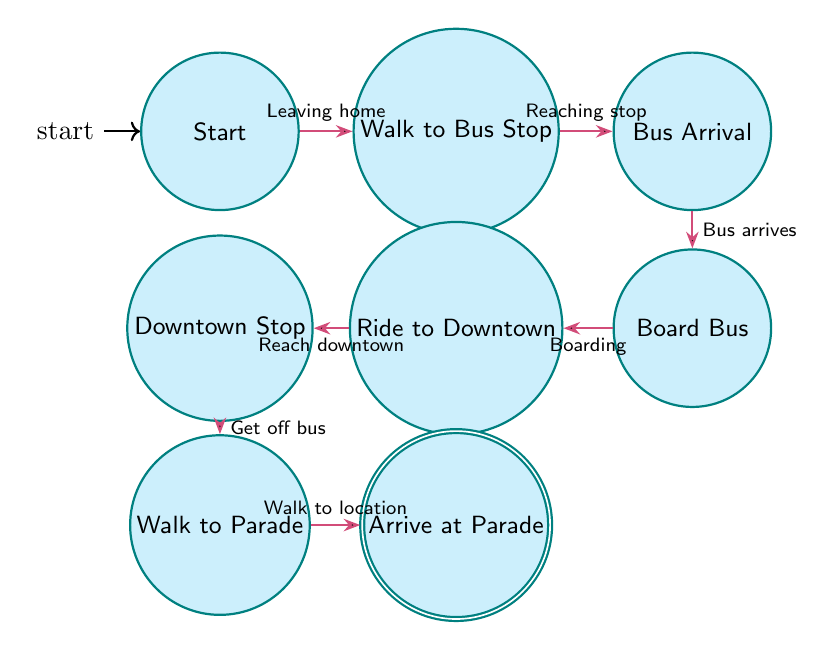What is the starting point in the diagram? The starting point is labeled "Start," which represents the location where a person begins their journey at home in Pittsburgh.
Answer: Start How many states are represented in the diagram? By counting the individual labeled states shown in the diagram, we find a total of 8 states, which include Start, Walk to Bus Stop, Bus Arrival, Board Bus, Ride to Downtown, Downtown Stop, Walk to Parade, and Arrive at Parade.
Answer: 8 What does the arrow from "Board Bus" to "Ride to Downtown" signify? The arrow indicates a transition from the state "Board Bus" to the state "Ride to Downtown," which occurs after boarding the bus. This shows the progress of the journey once the bus has been boarded.
Answer: Boarding What is the destination of the last state "Arrive at Parade"? The last state "Arrive at Parade" indicates the final destination of the journey, which is where the Pittsburgh Pride Parade takes place after following the transit steps.
Answer: Pittsburgh Pride Parade Which state follows "Bus Stop Downtown"? The state that directly follows "Bus Stop Downtown" in the sequence is "Walk to Parade," indicating the next action after getting off the bus downtown.
Answer: Walk to Parade What happens in the "Ride to Downtown" state? In the "Ride to Downtown" state, the individual is traveling on the bus that leads them toward downtown Pittsburgh but hasn't yet reached their stop. This is an operational aspect of their journey.
Answer: Traveling on the bus What is the relationship between "Walk to Bus Stop" and "Bus Arrival"? The relationship is sequential; after reaching the bus stop, the next state is "Bus Arrival," indicating the person waits for the bus after arriving at the stop.
Answer: Sequential What is the transition description from "Walk to Parade" to "Arrive at Parade"? The transition description indicates the action of walking towards the parade location after having made it to the local downtown area. This is the final leg of the journey.
Answer: Walking to location 